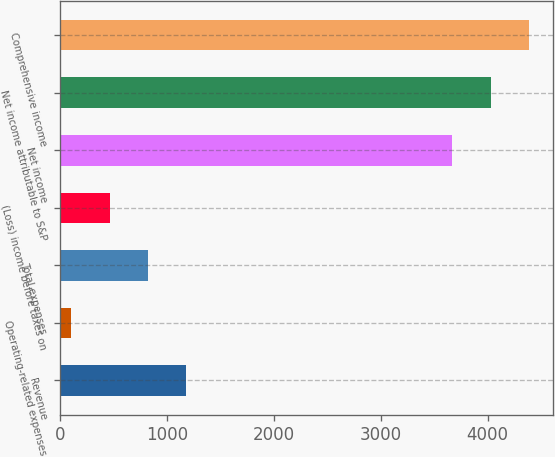Convert chart to OTSL. <chart><loc_0><loc_0><loc_500><loc_500><bar_chart><fcel>Revenue<fcel>Operating-related expenses<fcel>Total expenses<fcel>(Loss) income before taxes on<fcel>Net income<fcel>Net income attributable to S&P<fcel>Comprehensive income<nl><fcel>1183.8<fcel>108<fcel>825.2<fcel>466.6<fcel>3670<fcel>4028.6<fcel>4387.2<nl></chart> 